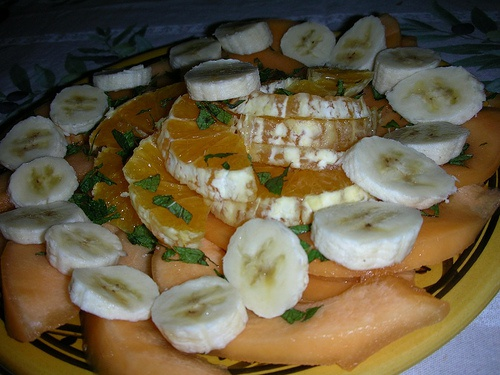Describe the objects in this image and their specific colors. I can see orange in black, olive, darkgray, and tan tones, banana in black, gray, darkgray, and darkgreen tones, banana in black, darkgray, lightgray, and gray tones, banana in black, darkgray, tan, and lightgray tones, and banana in black, darkgray, gray, and lightgray tones in this image. 